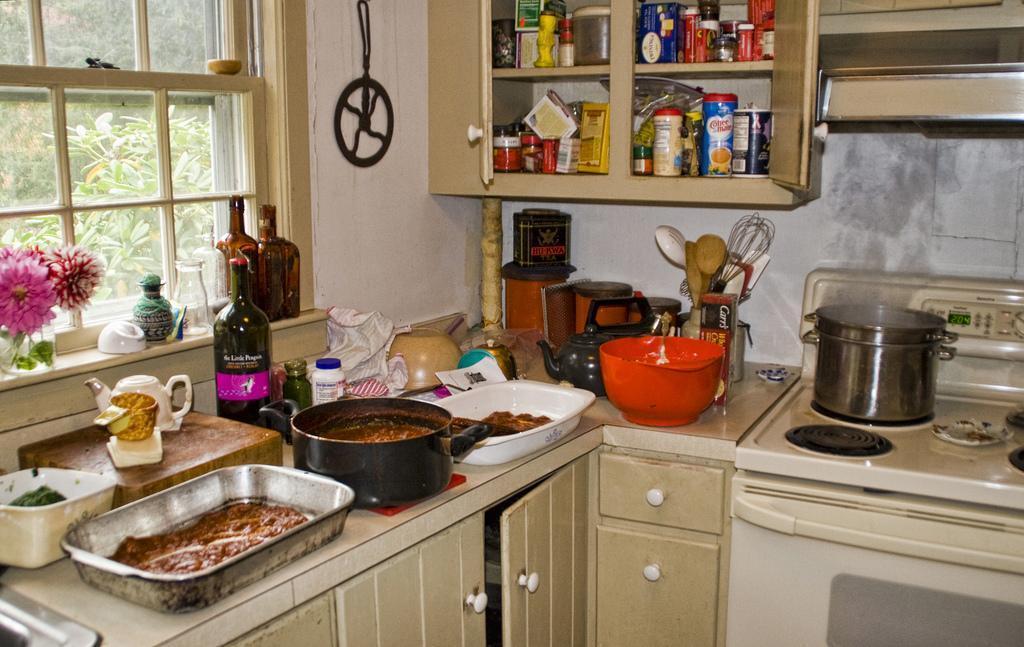How many black tea kettles are there in the image?
Give a very brief answer. 1. 